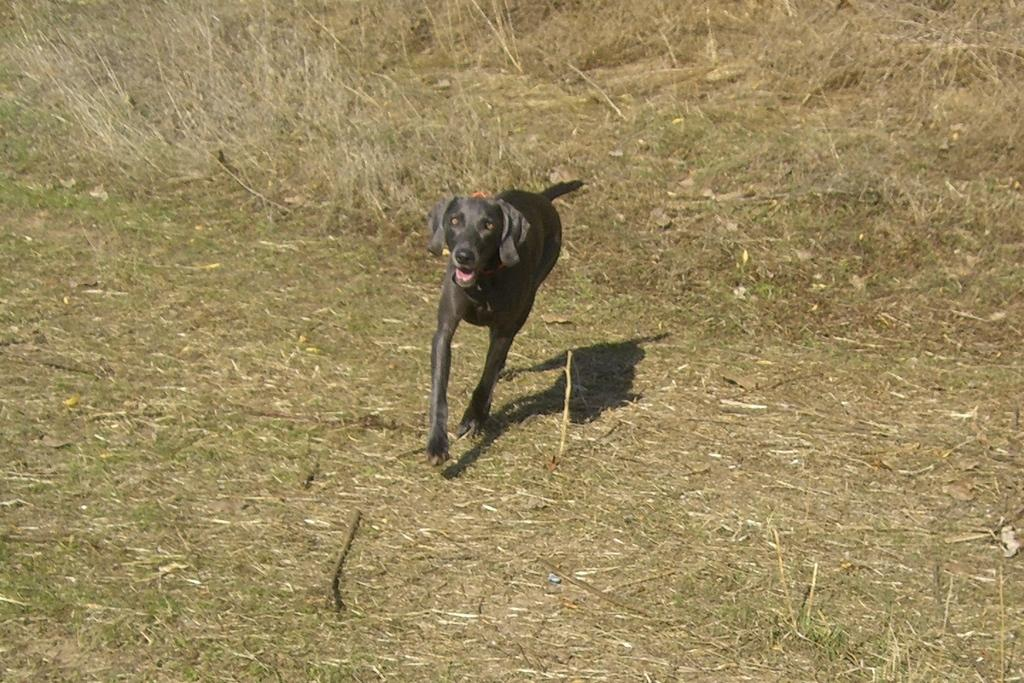What type of animal is in the picture? There is a black dog in the picture. What is the dog doing in the picture? The dog is running. What is the ground made of in the picture? There is grass on the ground in the picture. What type of plantation can be seen in the background of the image? There is no plantation present in the image; it features a black dog running on grass. What type of sail is visible on the dog in the image? There is no sail present in the image; it features a black dog running on grass. 